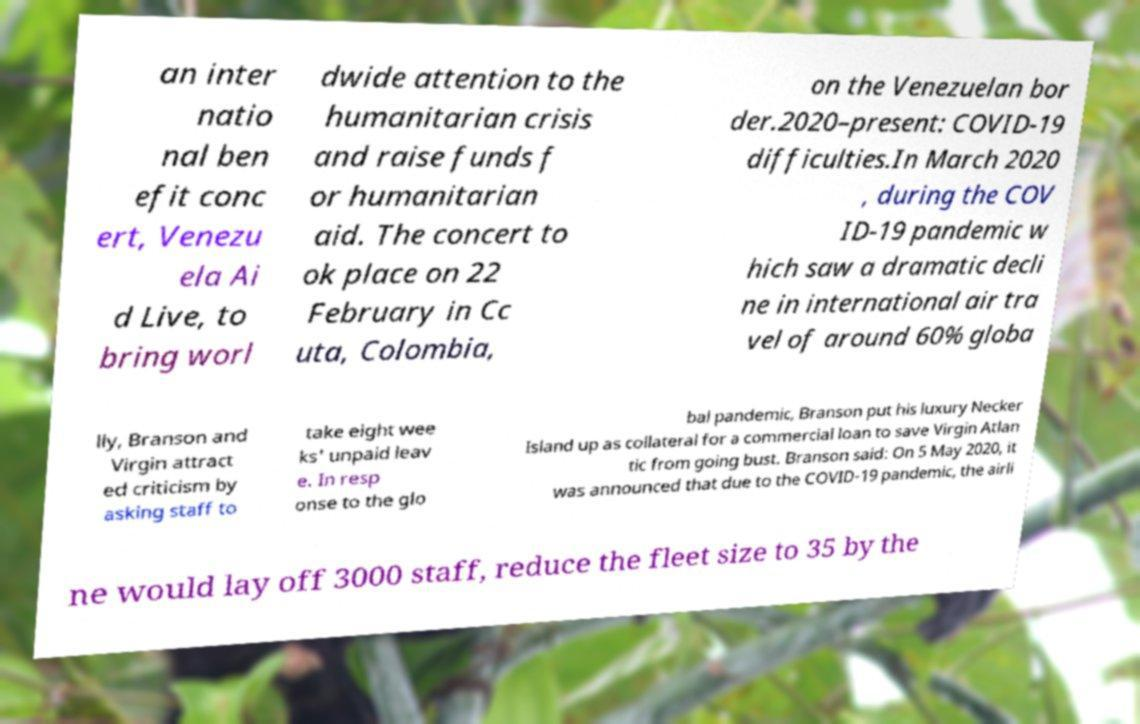Could you extract and type out the text from this image? an inter natio nal ben efit conc ert, Venezu ela Ai d Live, to bring worl dwide attention to the humanitarian crisis and raise funds f or humanitarian aid. The concert to ok place on 22 February in Cc uta, Colombia, on the Venezuelan bor der.2020–present: COVID-19 difficulties.In March 2020 , during the COV ID-19 pandemic w hich saw a dramatic decli ne in international air tra vel of around 60% globa lly, Branson and Virgin attract ed criticism by asking staff to take eight wee ks' unpaid leav e. In resp onse to the glo bal pandemic, Branson put his luxury Necker Island up as collateral for a commercial loan to save Virgin Atlan tic from going bust. Branson said: On 5 May 2020, it was announced that due to the COVID-19 pandemic, the airli ne would lay off 3000 staff, reduce the fleet size to 35 by the 